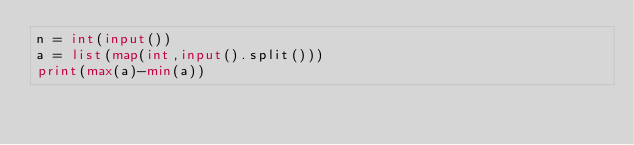<code> <loc_0><loc_0><loc_500><loc_500><_Python_>n = int(input())
a = list(map(int,input().split()))
print(max(a)-min(a))</code> 